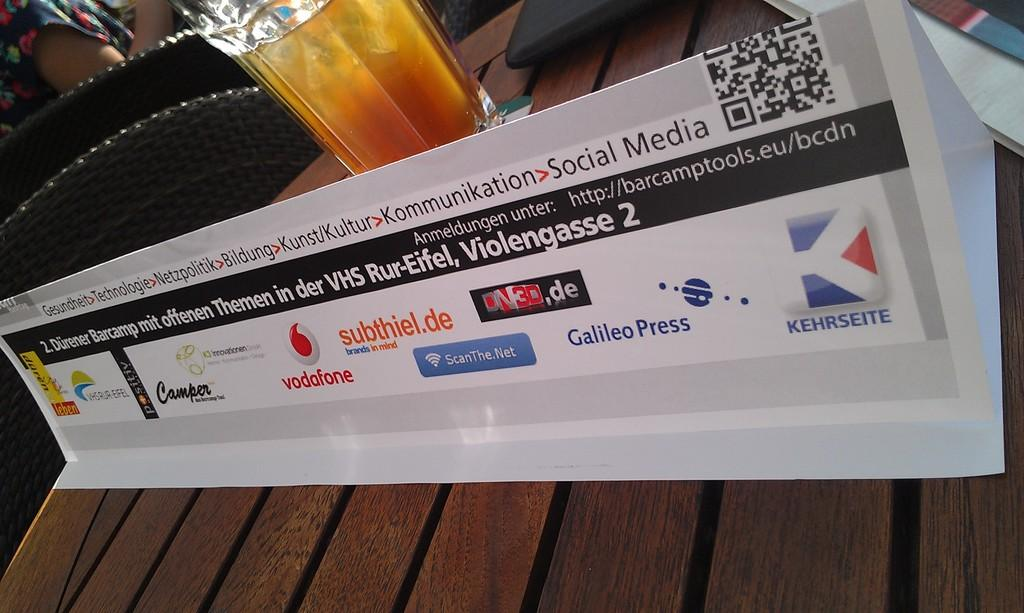<image>
Render a clear and concise summary of the photo. A white placard bearing business names such as vodafone sits in front of a glass of amber liquid on a wood table.. 